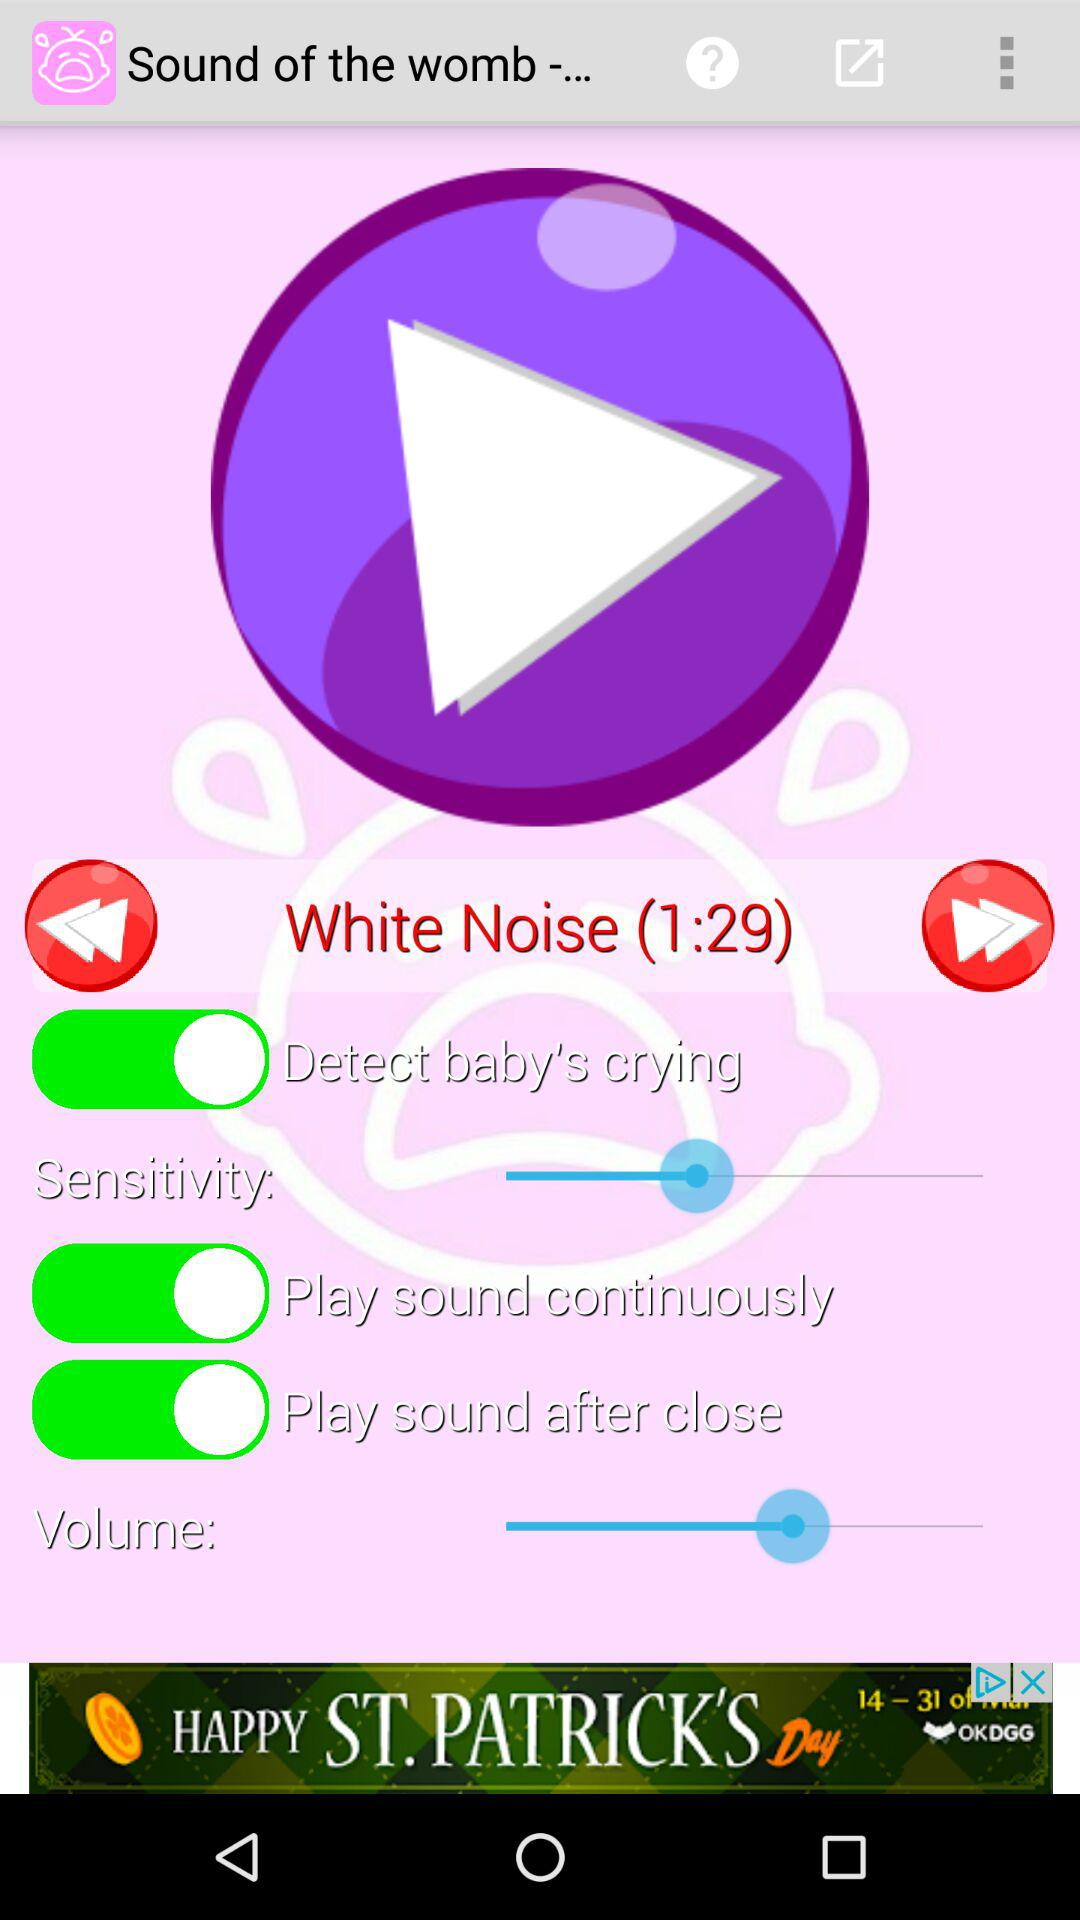What is the status of "Detect baby's crying"? The status of "Detect baby's crying" is "on". 